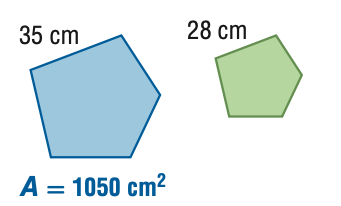Answer the mathemtical geometry problem and directly provide the correct option letter.
Question: For the pair of similar figures, find the area of the green figure.
Choices: A: 672 B: 840 C: 1313 D: 1641 A 